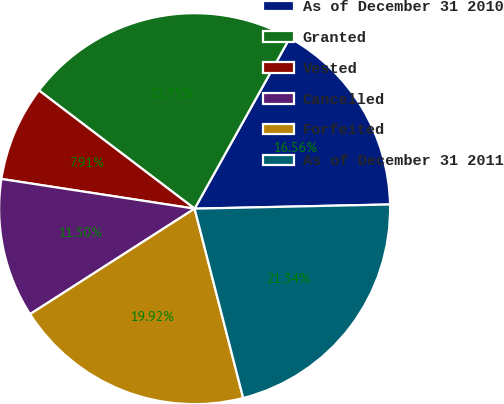Convert chart. <chart><loc_0><loc_0><loc_500><loc_500><pie_chart><fcel>As of December 31 2010<fcel>Granted<fcel>Vested<fcel>Cancelled<fcel>Forfeited<fcel>As of December 31 2011<nl><fcel>16.56%<fcel>22.75%<fcel>7.91%<fcel>11.5%<fcel>19.92%<fcel>21.34%<nl></chart> 